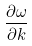Convert formula to latex. <formula><loc_0><loc_0><loc_500><loc_500>\frac { \partial \omega } { \partial k }</formula> 